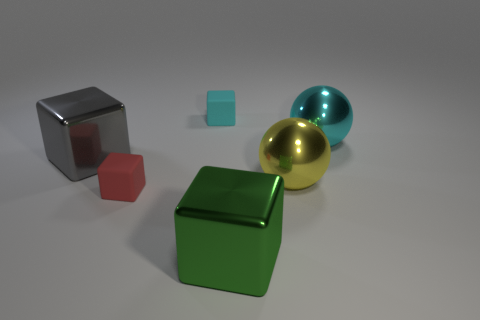What size is the object that is in front of the tiny red object?
Keep it short and to the point. Large. Does the rubber block that is in front of the small cyan rubber block have the same color as the small cube behind the tiny red matte cube?
Your answer should be very brief. No. How many other objects are there of the same shape as the green metal thing?
Your answer should be very brief. 3. Are there the same number of large gray things on the right side of the large gray shiny cube and big cubes that are to the right of the big yellow metal thing?
Provide a succinct answer. Yes. Is the material of the tiny block on the left side of the cyan rubber thing the same as the big cube left of the large green shiny block?
Offer a very short reply. No. What number of other things are the same size as the gray shiny cube?
Provide a short and direct response. 3. How many things are either small gray rubber blocks or small rubber things that are left of the cyan matte block?
Offer a terse response. 1. Is the number of large shiny things that are behind the yellow shiny object the same as the number of purple matte cylinders?
Ensure brevity in your answer.  No. What is the shape of the big green object that is the same material as the big yellow object?
Your response must be concise. Cube. What number of metal things are either tiny things or small red cubes?
Offer a terse response. 0. 